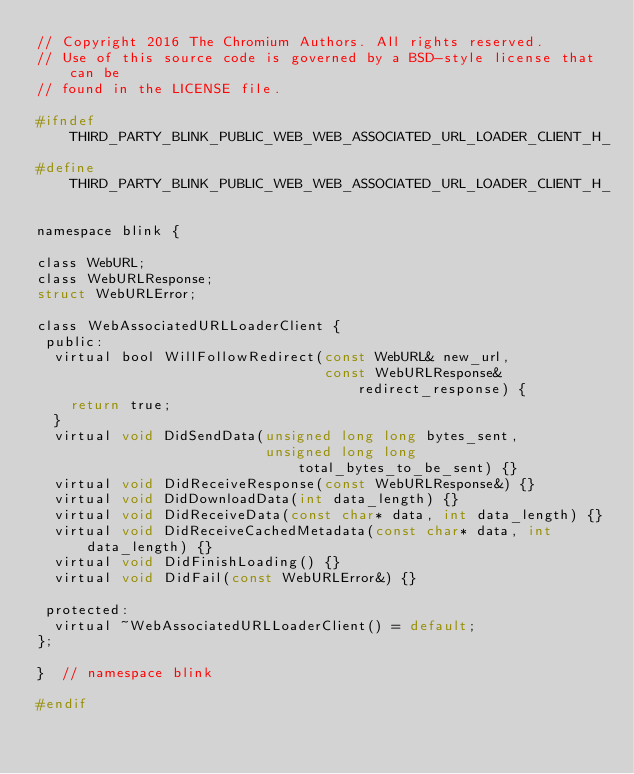Convert code to text. <code><loc_0><loc_0><loc_500><loc_500><_C_>// Copyright 2016 The Chromium Authors. All rights reserved.
// Use of this source code is governed by a BSD-style license that can be
// found in the LICENSE file.

#ifndef THIRD_PARTY_BLINK_PUBLIC_WEB_WEB_ASSOCIATED_URL_LOADER_CLIENT_H_
#define THIRD_PARTY_BLINK_PUBLIC_WEB_WEB_ASSOCIATED_URL_LOADER_CLIENT_H_

namespace blink {

class WebURL;
class WebURLResponse;
struct WebURLError;

class WebAssociatedURLLoaderClient {
 public:
  virtual bool WillFollowRedirect(const WebURL& new_url,
                                  const WebURLResponse& redirect_response) {
    return true;
  }
  virtual void DidSendData(unsigned long long bytes_sent,
                           unsigned long long total_bytes_to_be_sent) {}
  virtual void DidReceiveResponse(const WebURLResponse&) {}
  virtual void DidDownloadData(int data_length) {}
  virtual void DidReceiveData(const char* data, int data_length) {}
  virtual void DidReceiveCachedMetadata(const char* data, int data_length) {}
  virtual void DidFinishLoading() {}
  virtual void DidFail(const WebURLError&) {}

 protected:
  virtual ~WebAssociatedURLLoaderClient() = default;
};

}  // namespace blink

#endif
</code> 